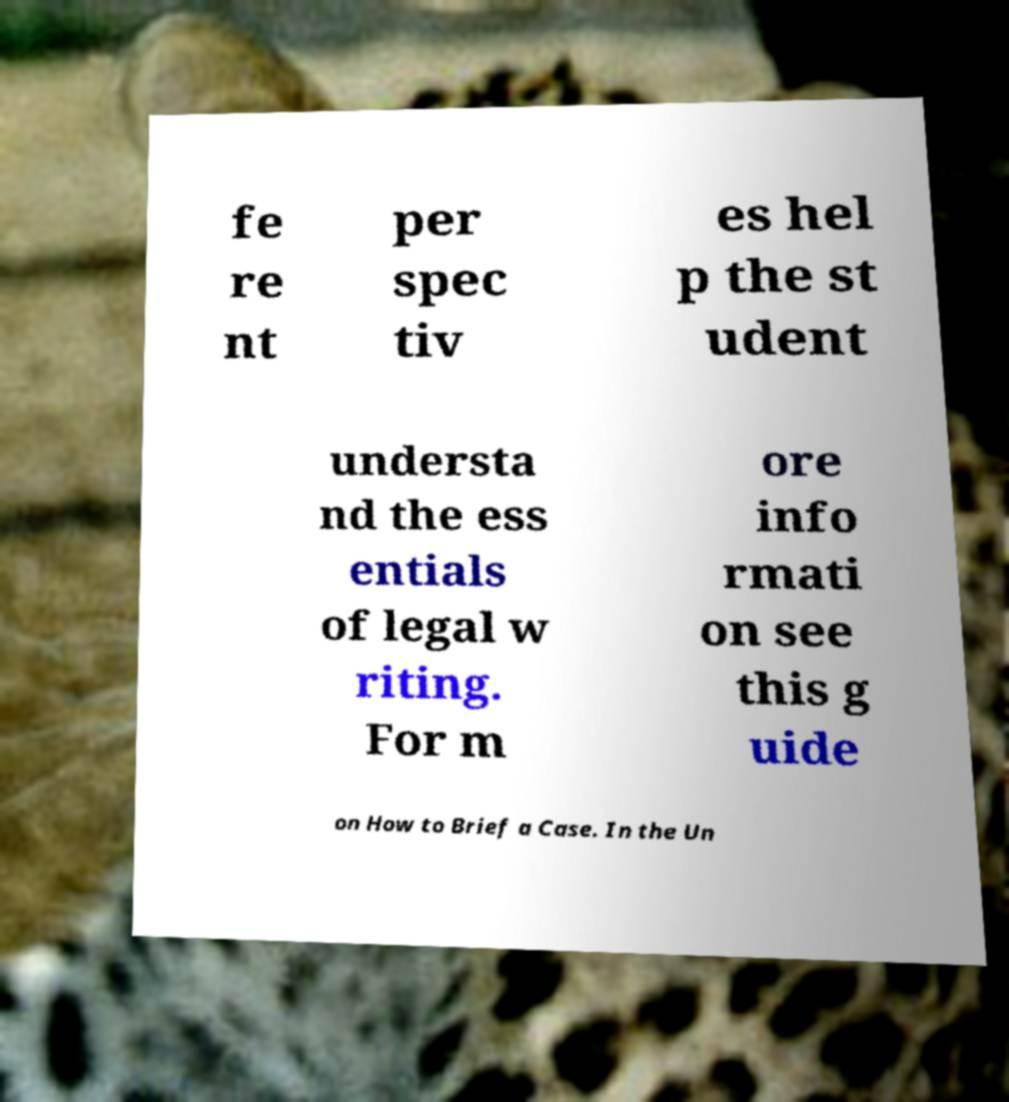Could you assist in decoding the text presented in this image and type it out clearly? fe re nt per spec tiv es hel p the st udent understa nd the ess entials of legal w riting. For m ore info rmati on see this g uide on How to Brief a Case. In the Un 